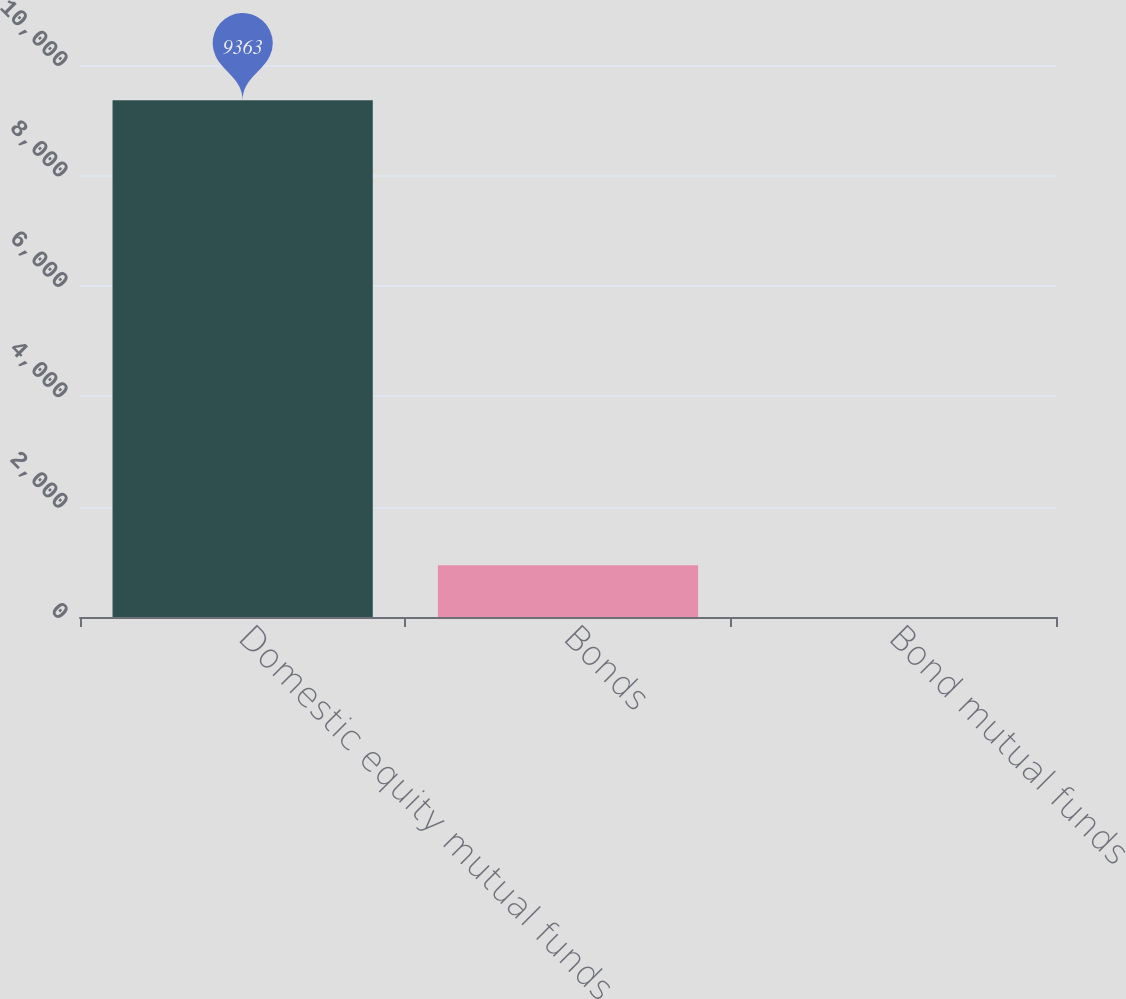Convert chart to OTSL. <chart><loc_0><loc_0><loc_500><loc_500><bar_chart><fcel>Domestic equity mutual funds<fcel>Bonds<fcel>Bond mutual funds<nl><fcel>9363<fcel>938.1<fcel>2<nl></chart> 